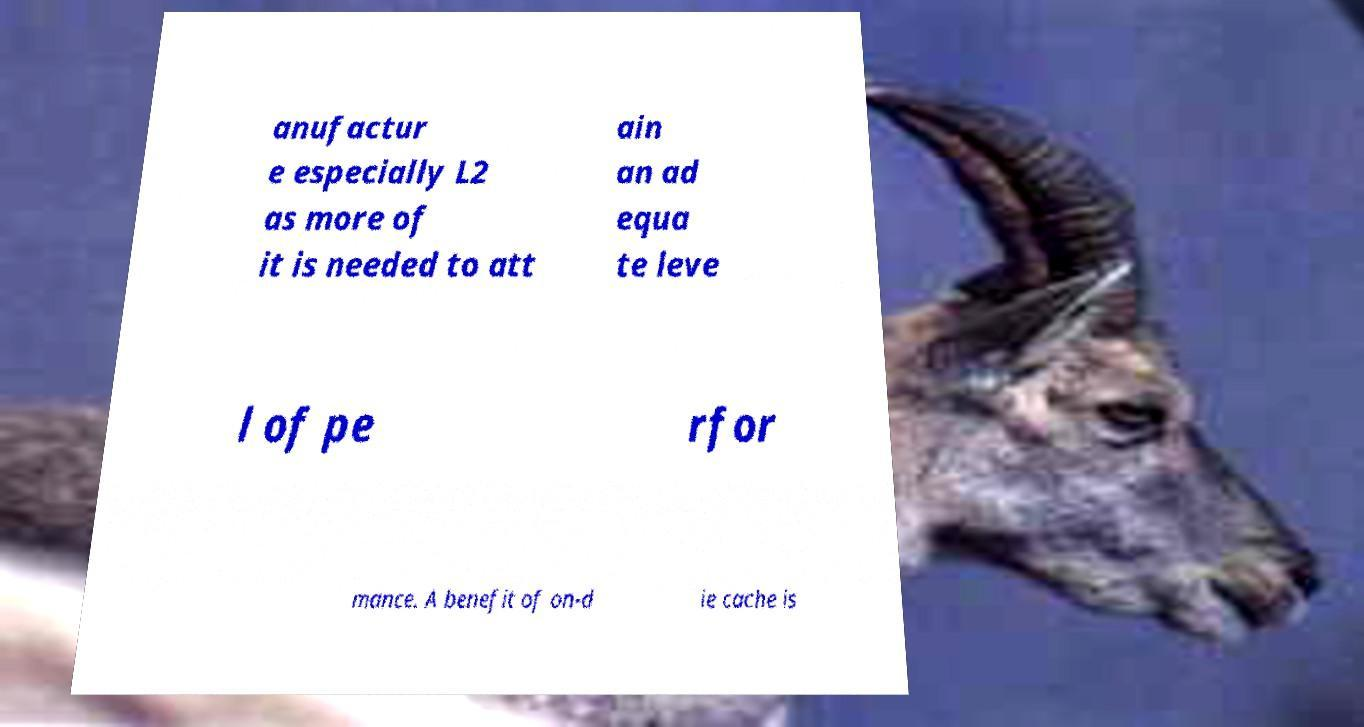Can you read and provide the text displayed in the image?This photo seems to have some interesting text. Can you extract and type it out for me? anufactur e especially L2 as more of it is needed to att ain an ad equa te leve l of pe rfor mance. A benefit of on-d ie cache is 